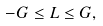<formula> <loc_0><loc_0><loc_500><loc_500>- G \leq L \leq G ,</formula> 